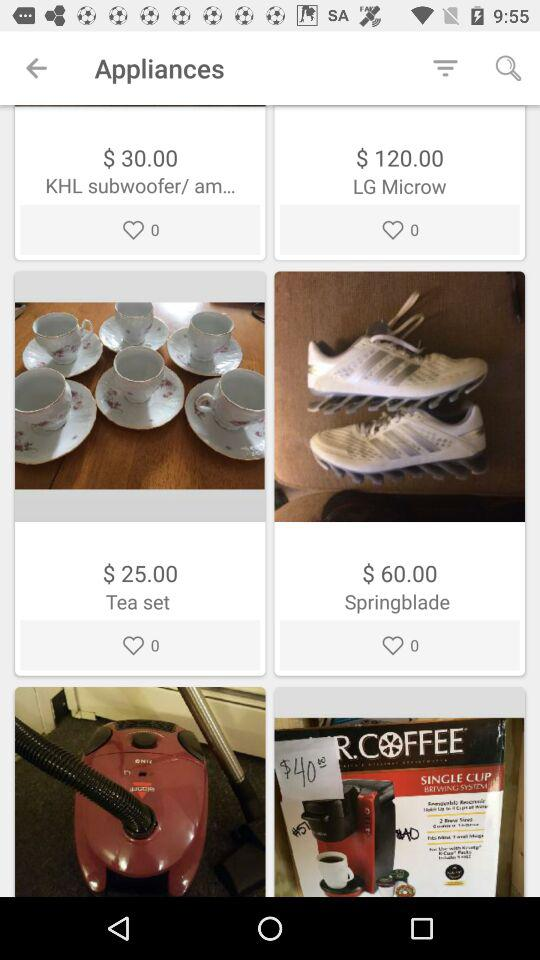How many items have a price of more than $30.00?
Answer the question using a single word or phrase. 2 